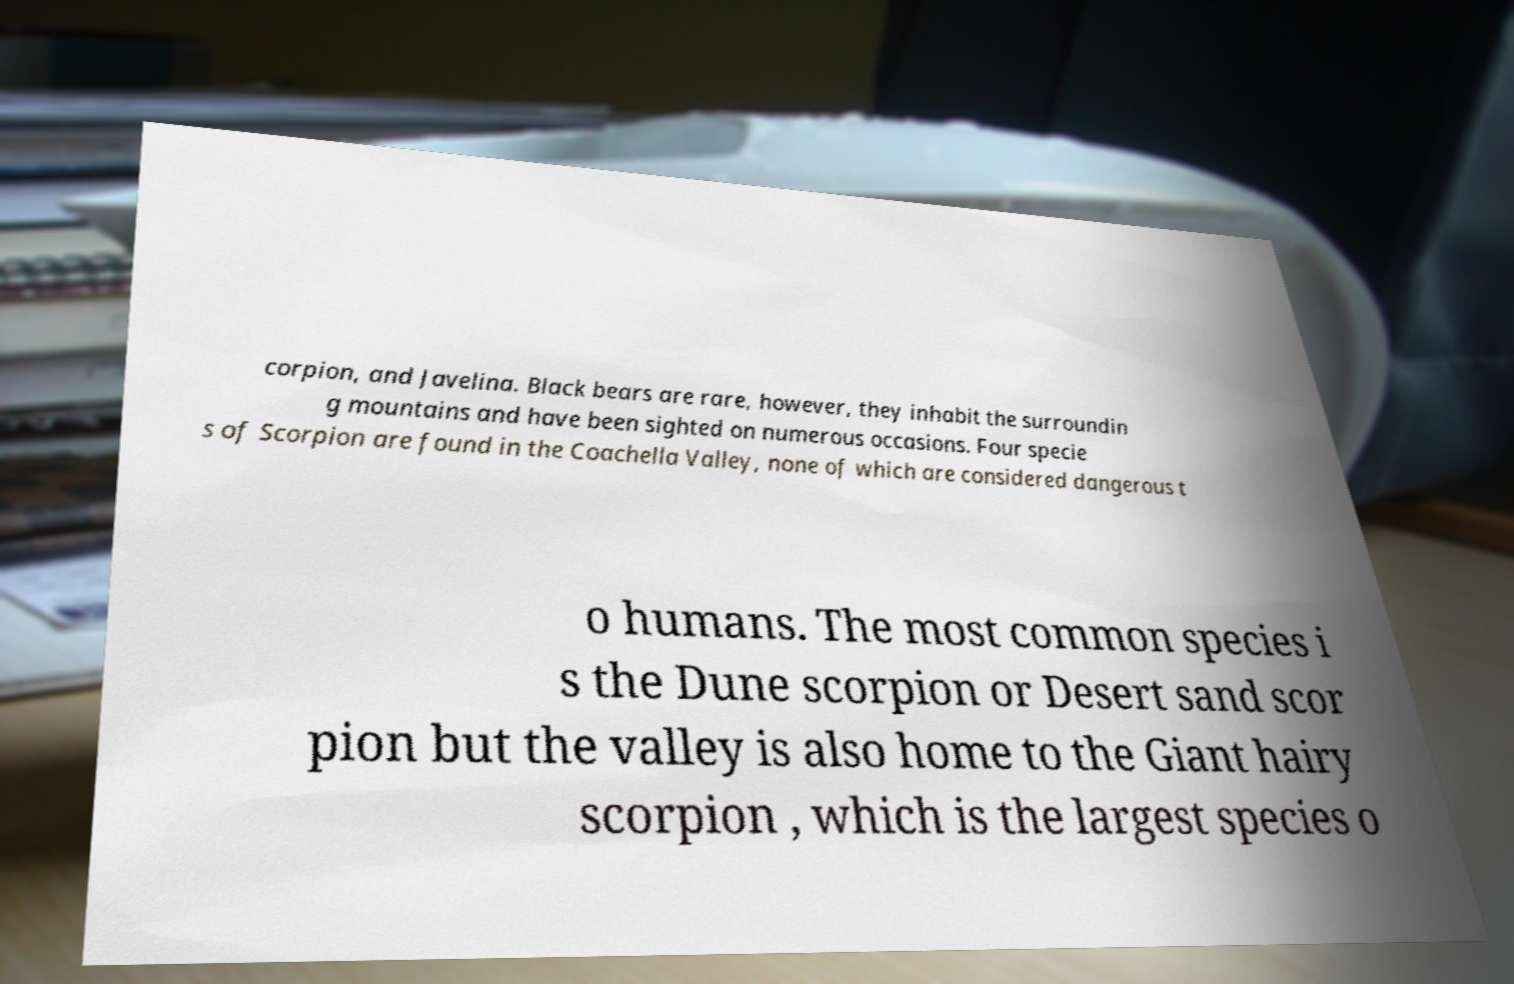There's text embedded in this image that I need extracted. Can you transcribe it verbatim? corpion, and Javelina. Black bears are rare, however, they inhabit the surroundin g mountains and have been sighted on numerous occasions. Four specie s of Scorpion are found in the Coachella Valley, none of which are considered dangerous t o humans. The most common species i s the Dune scorpion or Desert sand scor pion but the valley is also home to the Giant hairy scorpion , which is the largest species o 